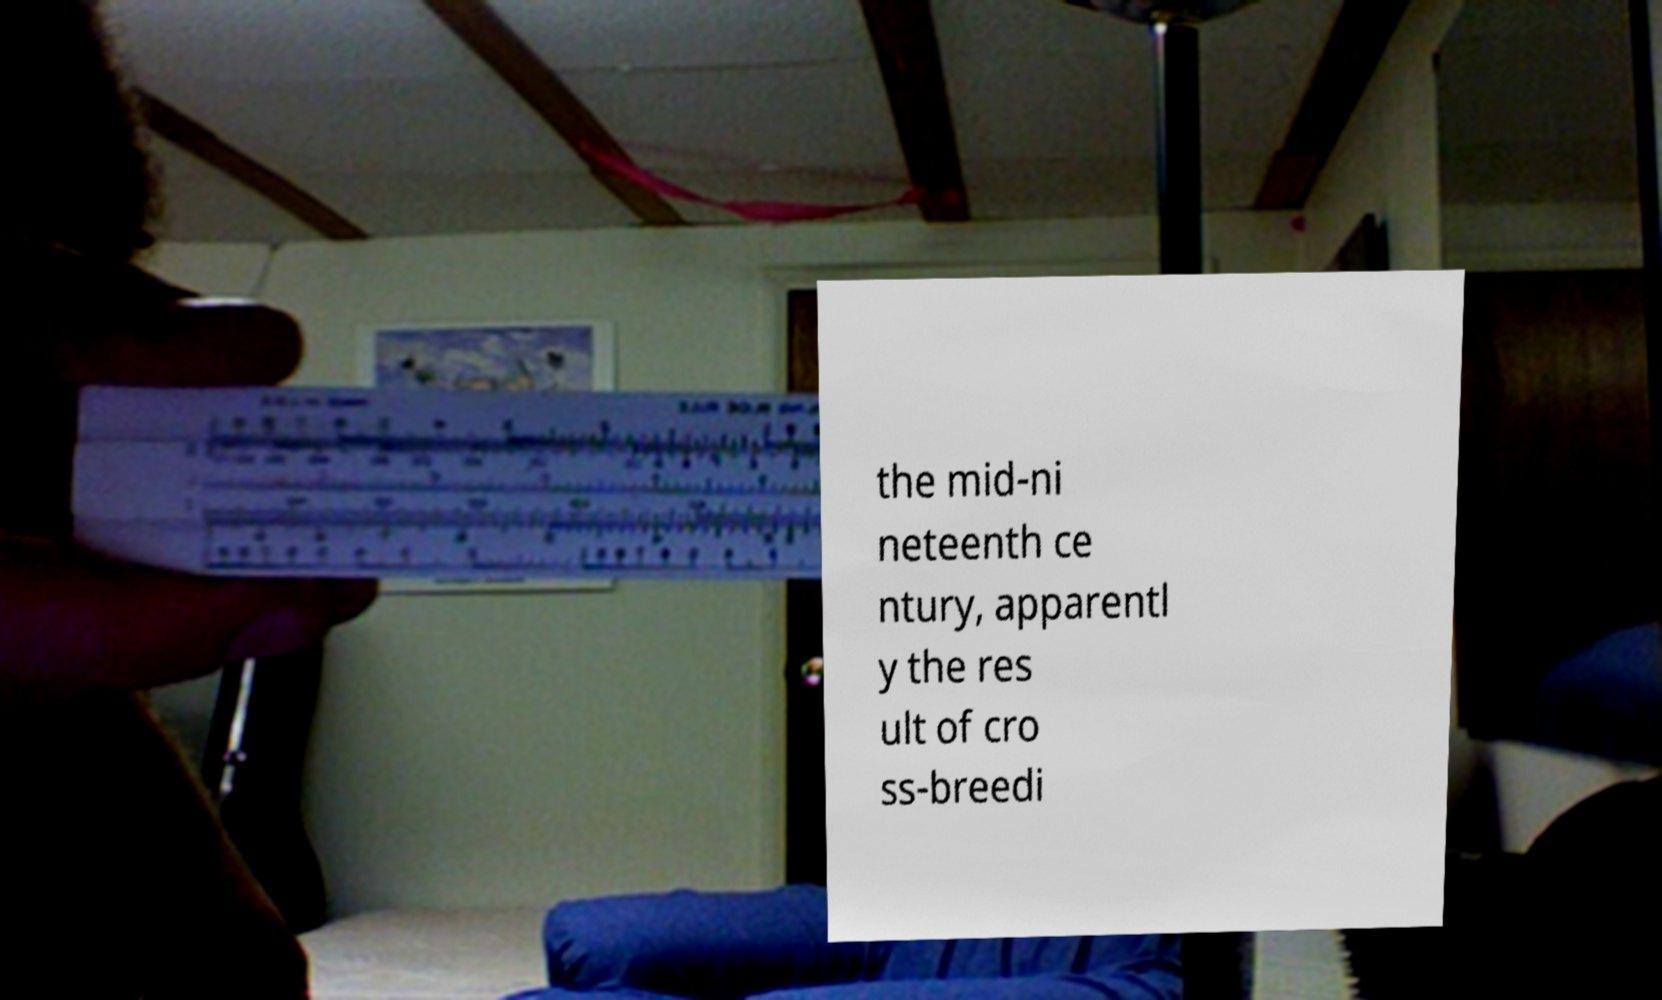Can you accurately transcribe the text from the provided image for me? the mid-ni neteenth ce ntury, apparentl y the res ult of cro ss-breedi 